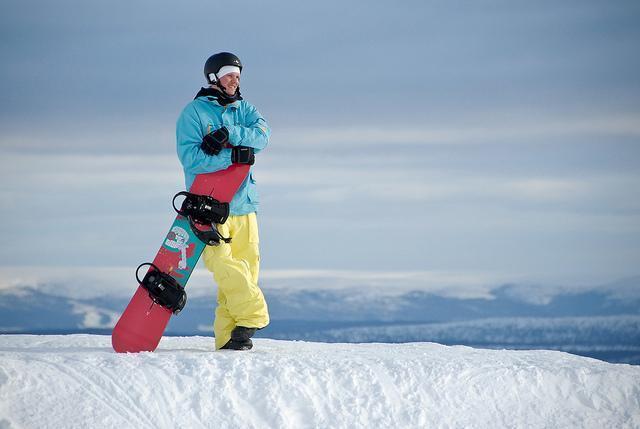How many elephants are there?
Give a very brief answer. 0. 